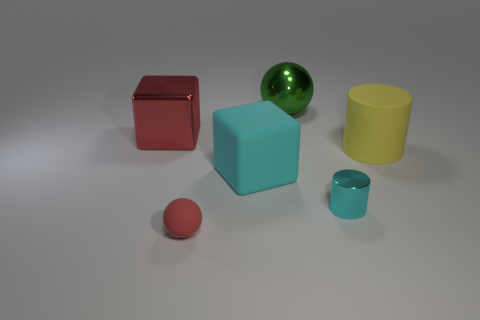Add 2 small shiny cylinders. How many objects exist? 8 Subtract all cylinders. How many objects are left? 4 Add 3 large cyan cubes. How many large cyan cubes are left? 4 Add 6 blue rubber spheres. How many blue rubber spheres exist? 6 Subtract 0 green cylinders. How many objects are left? 6 Subtract all large purple metallic spheres. Subtract all yellow cylinders. How many objects are left? 5 